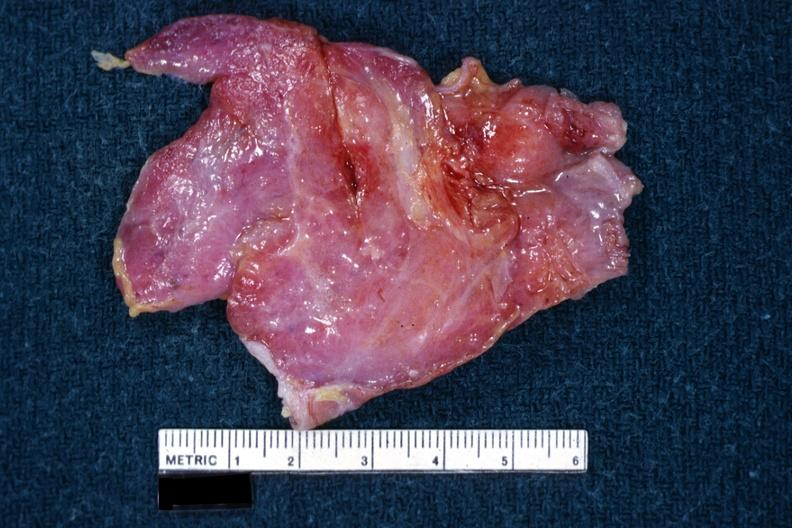what is present?
Answer the question using a single word or phrase. Thymoma 